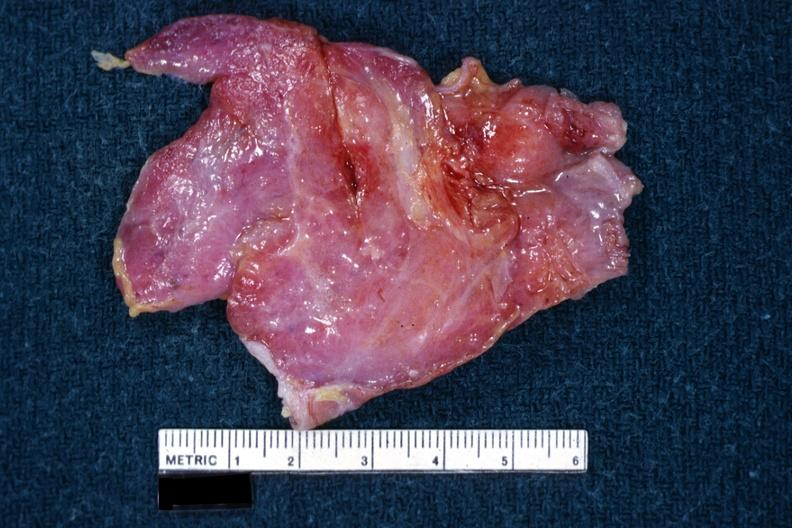what is present?
Answer the question using a single word or phrase. Thymoma 